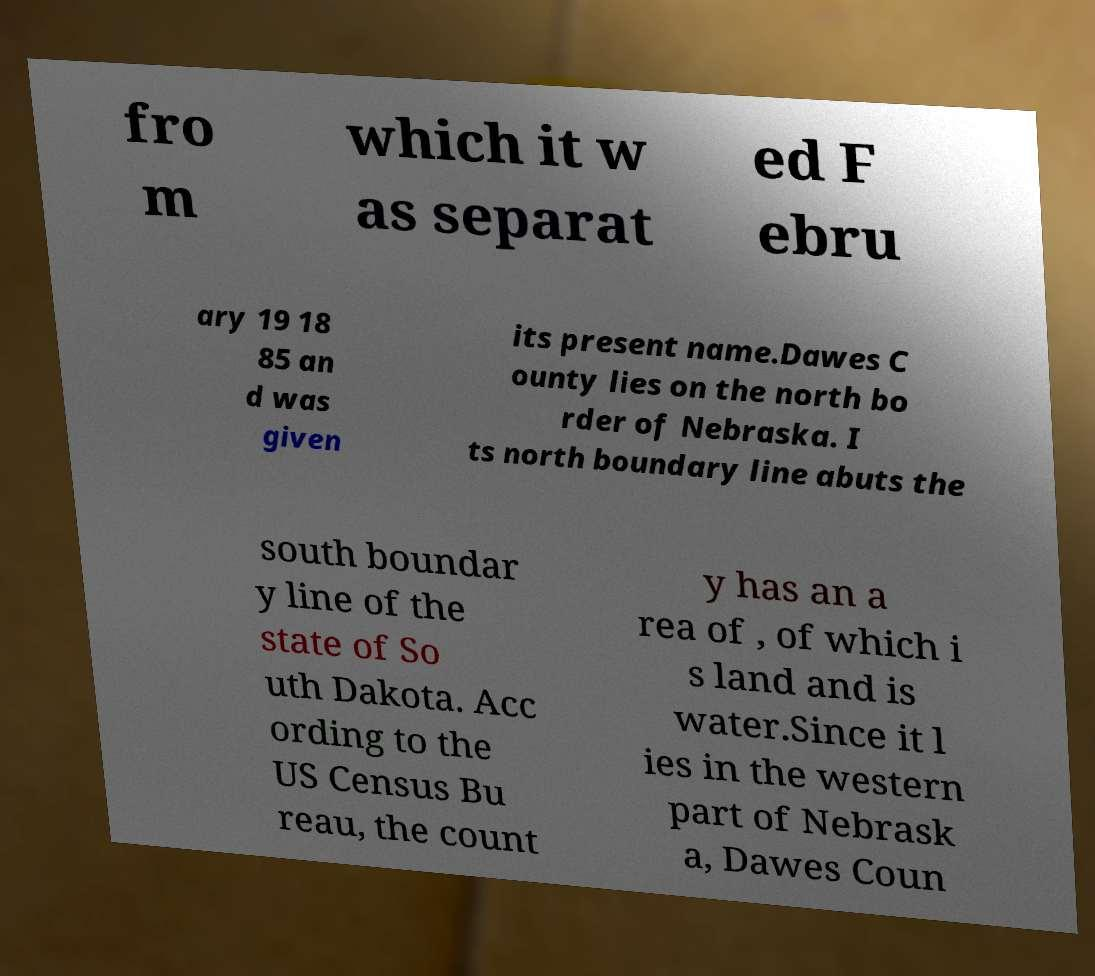What messages or text are displayed in this image? I need them in a readable, typed format. fro m which it w as separat ed F ebru ary 19 18 85 an d was given its present name.Dawes C ounty lies on the north bo rder of Nebraska. I ts north boundary line abuts the south boundar y line of the state of So uth Dakota. Acc ording to the US Census Bu reau, the count y has an a rea of , of which i s land and is water.Since it l ies in the western part of Nebrask a, Dawes Coun 